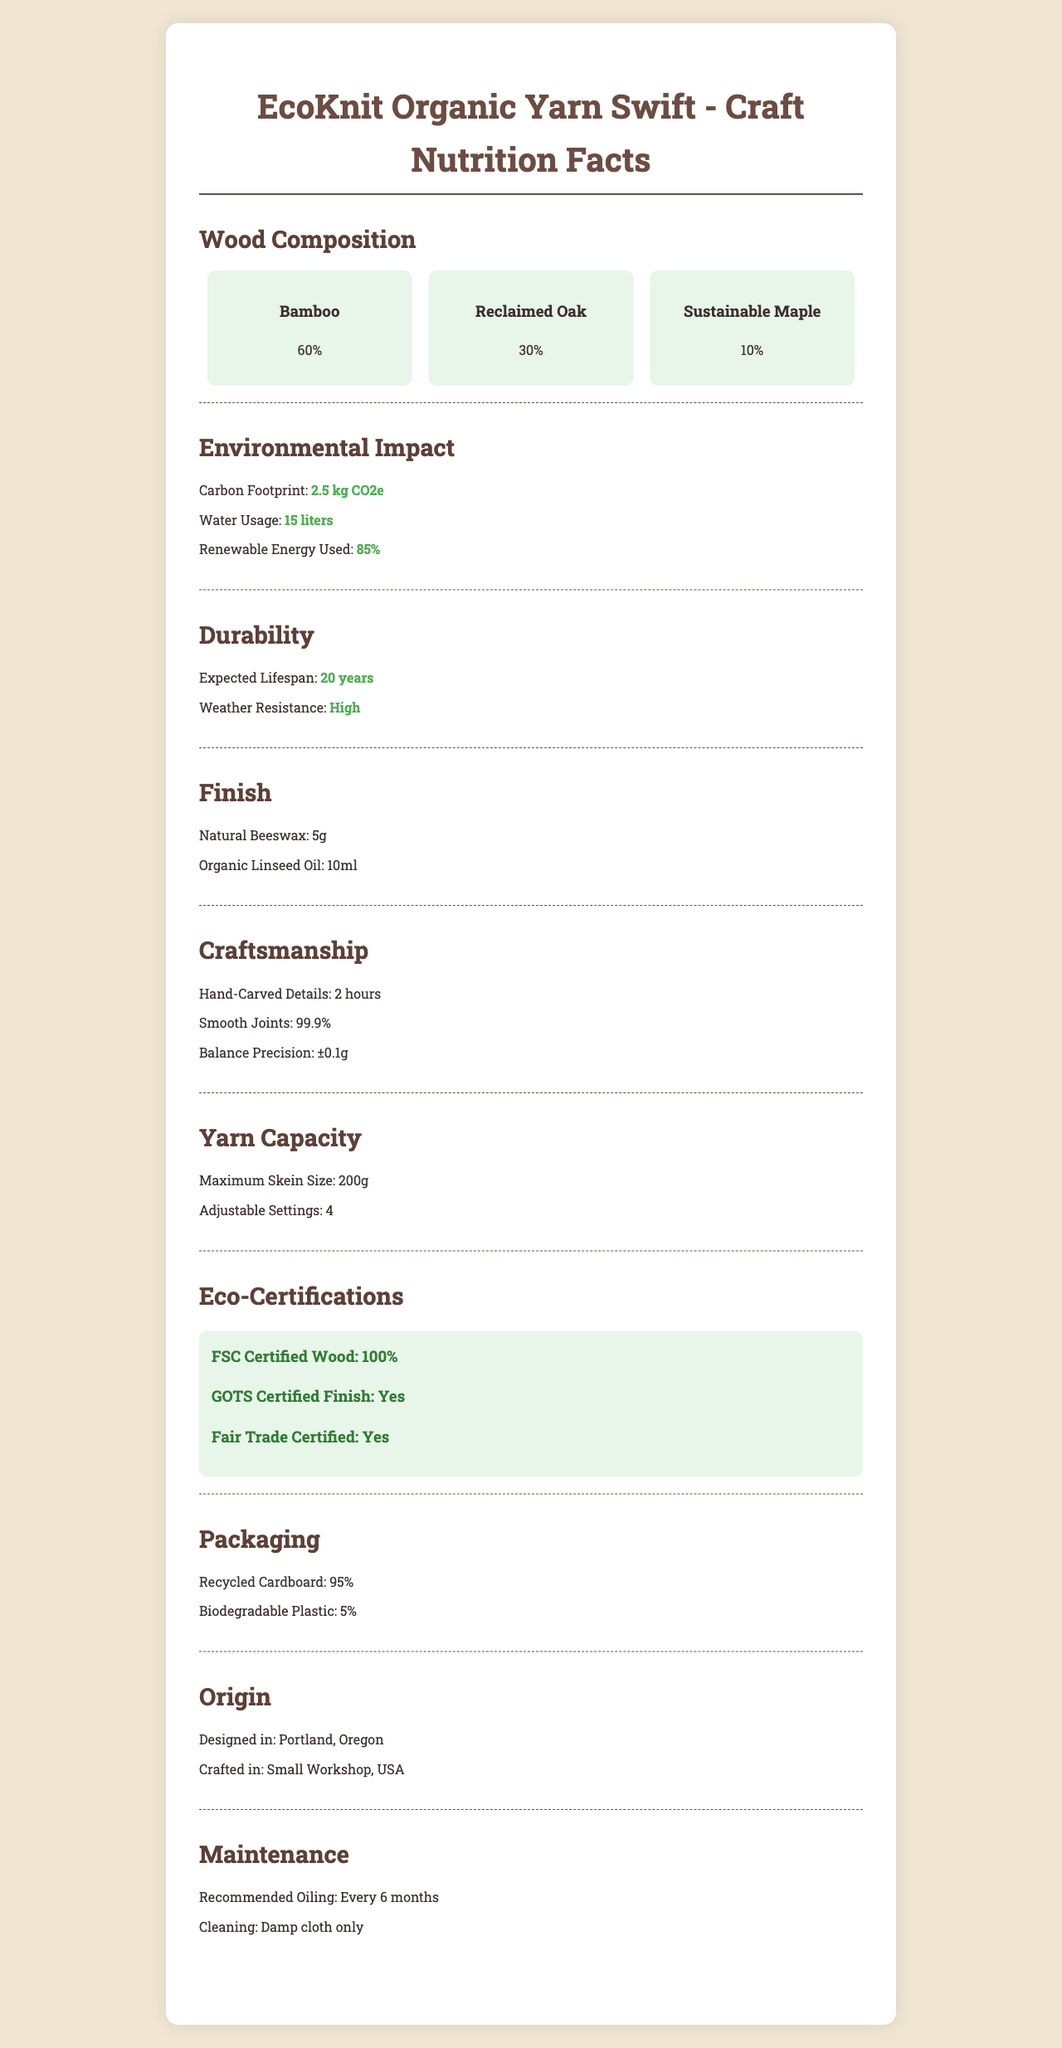what is the product name? The product name is listed at the top of the document under "Product Name".
Answer: EcoKnit Organic Yarn Swift what are the main wood types used in the yarn swift? The section "Wood Composition" lists the main wood types used.
Answer: Bamboo, Reclaimed Oak, Sustainable Maple how much organic linseed oil is used in the finish? The "Finish" section specifies "Organic Linseed Oil: 10ml".
Answer: 10ml what is the yarn swift's expected lifespan? The "Durability" section mentions the expected lifespan as "20 years".
Answer: 20 years what is the carbon footprint of the product? The "Environmental Impact" section states "Carbon Footprint: 2.5 kg CO2e".
Answer: 2.5 kg CO2e which wood type is used the most? A. Bamboo B. Reclaimed Oak C. Sustainable Maple D. Pine The "Wood Composition" section shows Bamboo at 60%, making it the most used wood type.
Answer: A. Bamboo which of the following certifications does the product have? A. GOTS Certified Finish B. Fair Trade Certified C. Both D. None The "Eco-Certifications" section shows that the product is both GOTS Certified Finish and Fair Trade Certified.
Answer: C. Both is the craftsmanship process hand-crafted? The "Craftsmanship" section highlights "Hand-Carved Details: 2 hours", indicating the process is hand-crafted.
Answer: Yes does the packaging use recycled materials? The "Packaging" section mentions "Recycled Cardboard: 95%", indicating the use of recycled materials.
Answer: Yes summarize the main characteristics of the EcoKnit Organic Yarn Swift. The document details the composition, environmental impact, durability, finish, craftsmanship, yarn capacity, eco-certifications, packaging, origin, and maintenance of the product.
Answer: The EcoKnit Organic Yarn Swift is a sustainable and eco-friendly product made primarily from bamboo, reclaimed oak, and sustainable maple. It has a minimal carbon footprint, uses renewable energy, and is durable with an expected lifespan of 20 years. The craftsmanship involves hand-carved details, and the product is certified by FSC, GOTS, and Fair Trade. It comes in recycled cardboard packaging and requires biannual oiling for maintenance. how often should the yarn swift be oiled? The "Maintenance" section states that oiling is recommended every 6 months.
Answer: Every 6 months where is the yarn swift designed? The "Origin" section mentions "Designed in: Portland, Oregon".
Answer: Portland, Oregon which finish components are used on the yarn swift? The "Finish" section lists the components as "Natural Beeswax: 5g" and "Organic Linseed Oil: 10ml".
Answer: Natural Beeswax and Organic Linseed Oil what is the balance precision of the craftsmanship? The "Craftsmanship" section states "Balance Precision: ±0.1g".
Answer: ±0.1g is it stated how much carbon was already sequestered by the bamboo used in the swift? The document does not provide specific information on how much carbon was sequestered by the bamboo used in the swift.
Answer: Cannot be determined 